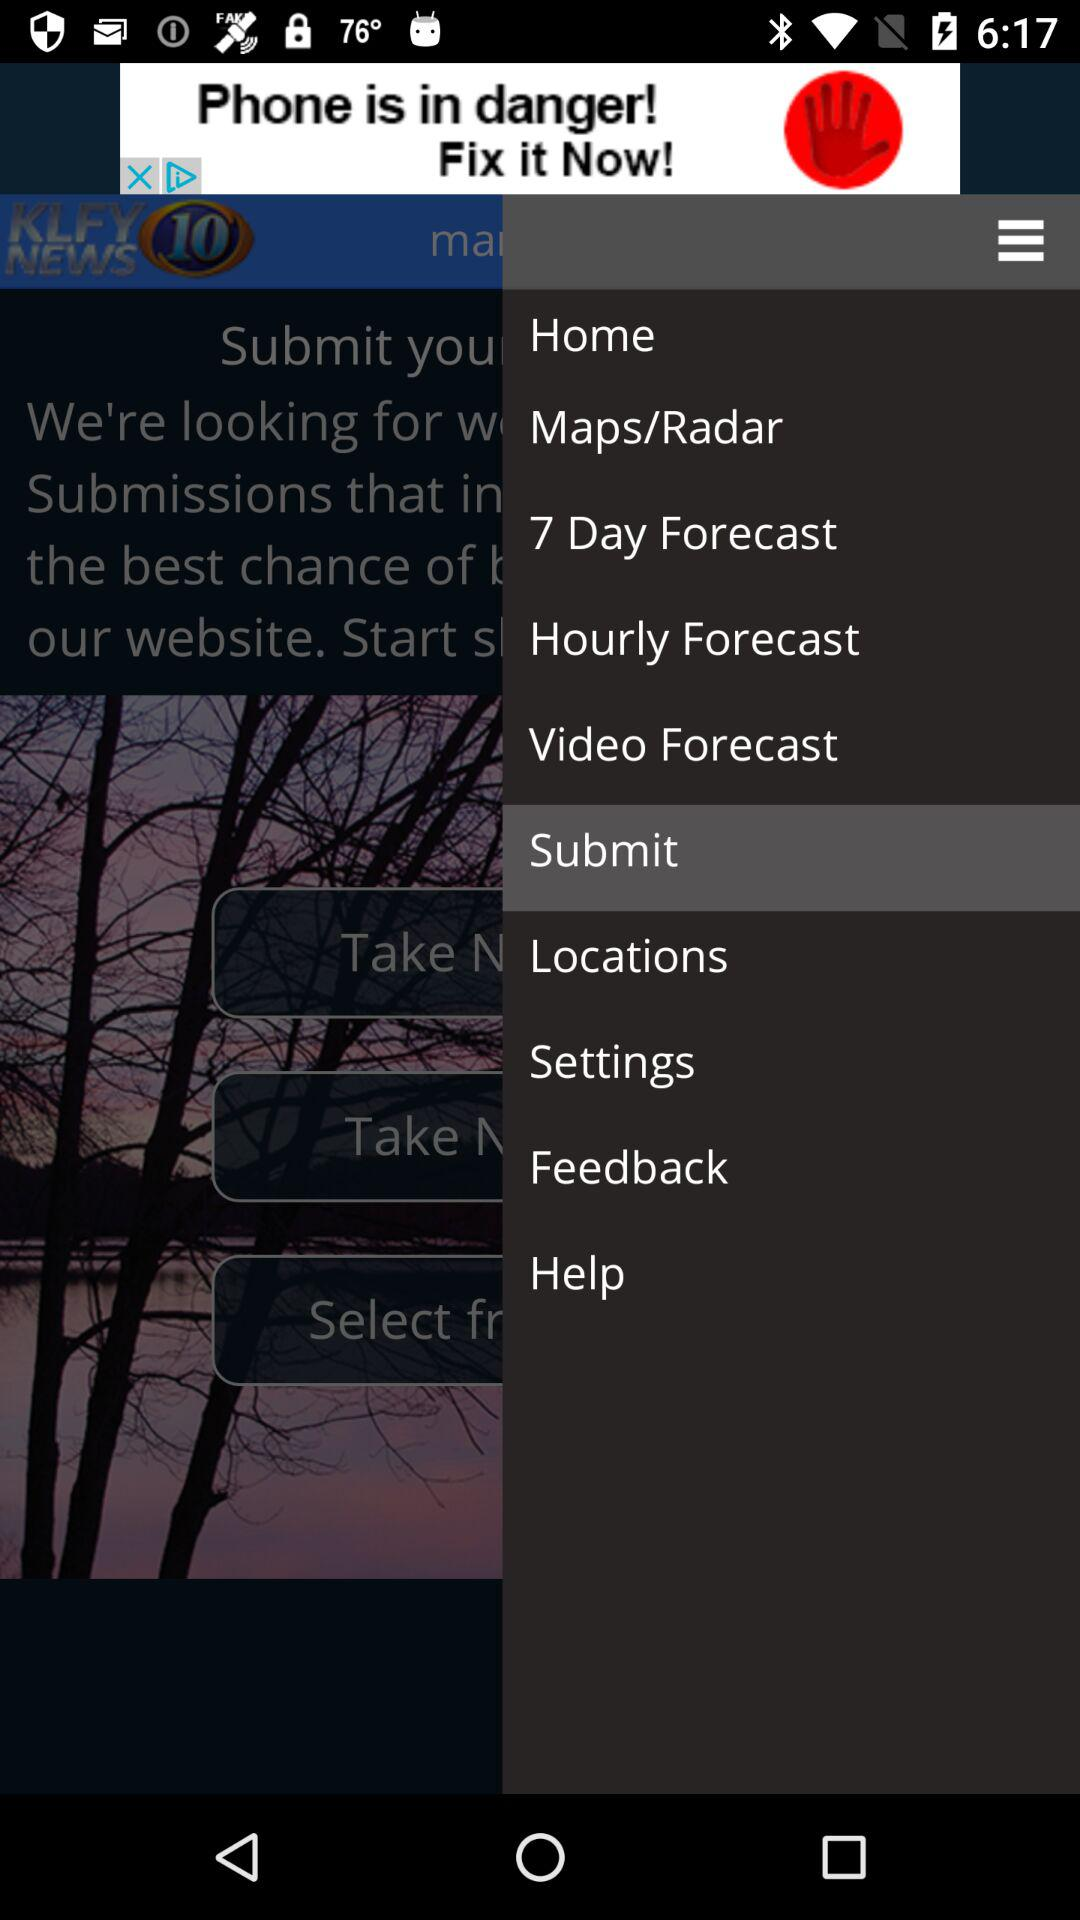How many days will be rainy in the coming week?
When the provided information is insufficient, respond with <no answer>. <no answer> 